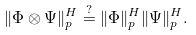Convert formula to latex. <formula><loc_0><loc_0><loc_500><loc_500>\| \Phi \otimes \Psi \| _ { p } ^ { H } \stackrel { ? } { = } \| \Phi \| _ { p } ^ { H } \| \Psi \| _ { p } ^ { H } .</formula> 